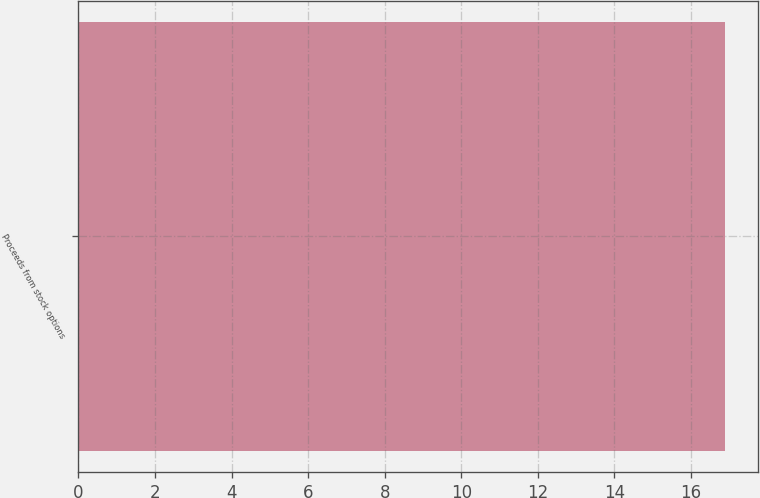Convert chart to OTSL. <chart><loc_0><loc_0><loc_500><loc_500><bar_chart><fcel>Proceeds from stock options<nl><fcel>16.9<nl></chart> 